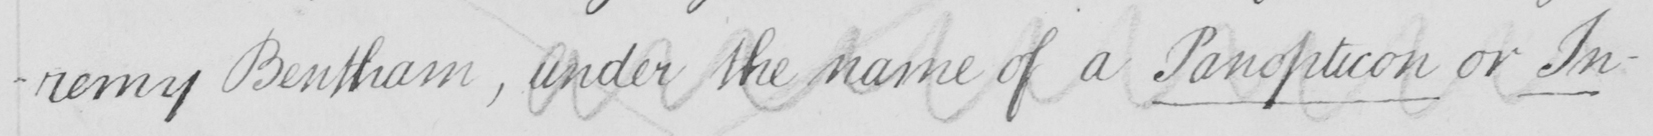Please transcribe the handwritten text in this image. -remy Bentham , under the name of a Panopticon or In- 